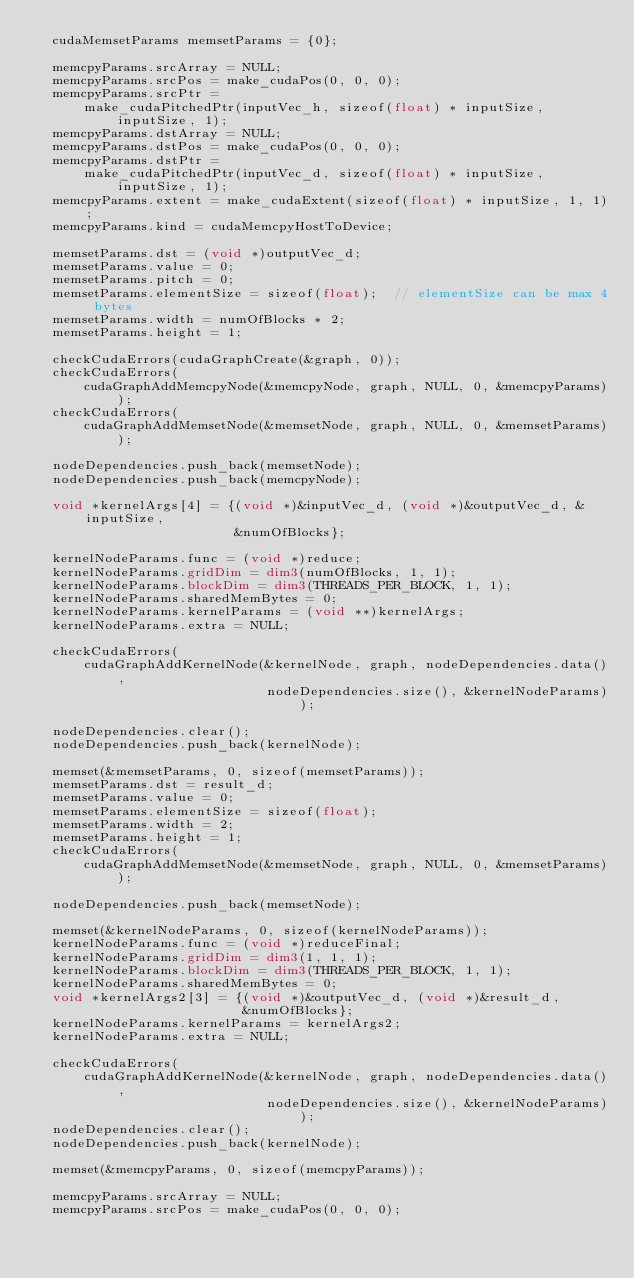<code> <loc_0><loc_0><loc_500><loc_500><_Cuda_>  cudaMemsetParams memsetParams = {0};

  memcpyParams.srcArray = NULL;
  memcpyParams.srcPos = make_cudaPos(0, 0, 0);
  memcpyParams.srcPtr =
      make_cudaPitchedPtr(inputVec_h, sizeof(float) * inputSize, inputSize, 1);
  memcpyParams.dstArray = NULL;
  memcpyParams.dstPos = make_cudaPos(0, 0, 0);
  memcpyParams.dstPtr =
      make_cudaPitchedPtr(inputVec_d, sizeof(float) * inputSize, inputSize, 1);
  memcpyParams.extent = make_cudaExtent(sizeof(float) * inputSize, 1, 1);
  memcpyParams.kind = cudaMemcpyHostToDevice;

  memsetParams.dst = (void *)outputVec_d;
  memsetParams.value = 0;
  memsetParams.pitch = 0;
  memsetParams.elementSize = sizeof(float);  // elementSize can be max 4 bytes
  memsetParams.width = numOfBlocks * 2;
  memsetParams.height = 1;

  checkCudaErrors(cudaGraphCreate(&graph, 0));
  checkCudaErrors(
      cudaGraphAddMemcpyNode(&memcpyNode, graph, NULL, 0, &memcpyParams));
  checkCudaErrors(
      cudaGraphAddMemsetNode(&memsetNode, graph, NULL, 0, &memsetParams));

  nodeDependencies.push_back(memsetNode);
  nodeDependencies.push_back(memcpyNode);

  void *kernelArgs[4] = {(void *)&inputVec_d, (void *)&outputVec_d, &inputSize,
                         &numOfBlocks};

  kernelNodeParams.func = (void *)reduce;
  kernelNodeParams.gridDim = dim3(numOfBlocks, 1, 1);
  kernelNodeParams.blockDim = dim3(THREADS_PER_BLOCK, 1, 1);
  kernelNodeParams.sharedMemBytes = 0;
  kernelNodeParams.kernelParams = (void **)kernelArgs;
  kernelNodeParams.extra = NULL;

  checkCudaErrors(
      cudaGraphAddKernelNode(&kernelNode, graph, nodeDependencies.data(),
                             nodeDependencies.size(), &kernelNodeParams));

  nodeDependencies.clear();
  nodeDependencies.push_back(kernelNode);

  memset(&memsetParams, 0, sizeof(memsetParams));
  memsetParams.dst = result_d;
  memsetParams.value = 0;
  memsetParams.elementSize = sizeof(float);
  memsetParams.width = 2;
  memsetParams.height = 1;
  checkCudaErrors(
      cudaGraphAddMemsetNode(&memsetNode, graph, NULL, 0, &memsetParams));

  nodeDependencies.push_back(memsetNode);

  memset(&kernelNodeParams, 0, sizeof(kernelNodeParams));
  kernelNodeParams.func = (void *)reduceFinal;
  kernelNodeParams.gridDim = dim3(1, 1, 1);
  kernelNodeParams.blockDim = dim3(THREADS_PER_BLOCK, 1, 1);
  kernelNodeParams.sharedMemBytes = 0;
  void *kernelArgs2[3] = {(void *)&outputVec_d, (void *)&result_d,
                          &numOfBlocks};
  kernelNodeParams.kernelParams = kernelArgs2;
  kernelNodeParams.extra = NULL;

  checkCudaErrors(
      cudaGraphAddKernelNode(&kernelNode, graph, nodeDependencies.data(),
                             nodeDependencies.size(), &kernelNodeParams));
  nodeDependencies.clear();
  nodeDependencies.push_back(kernelNode);

  memset(&memcpyParams, 0, sizeof(memcpyParams));

  memcpyParams.srcArray = NULL;
  memcpyParams.srcPos = make_cudaPos(0, 0, 0);</code> 